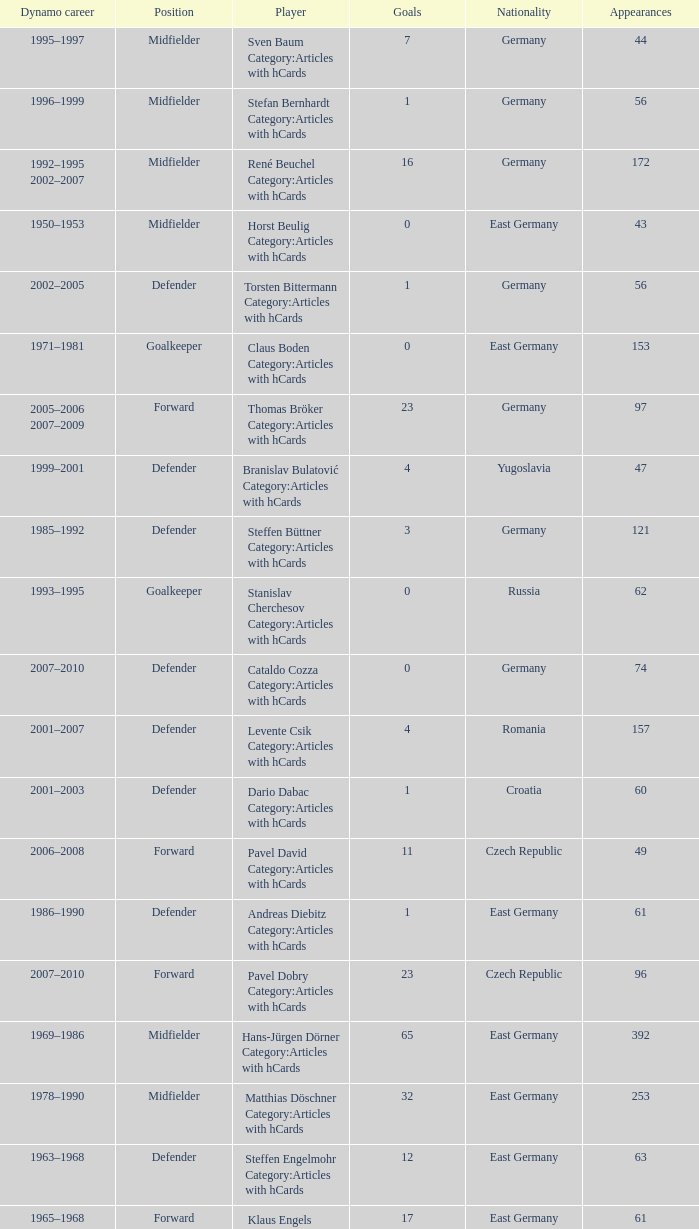What was the position of the player with 57 goals? Forward. 